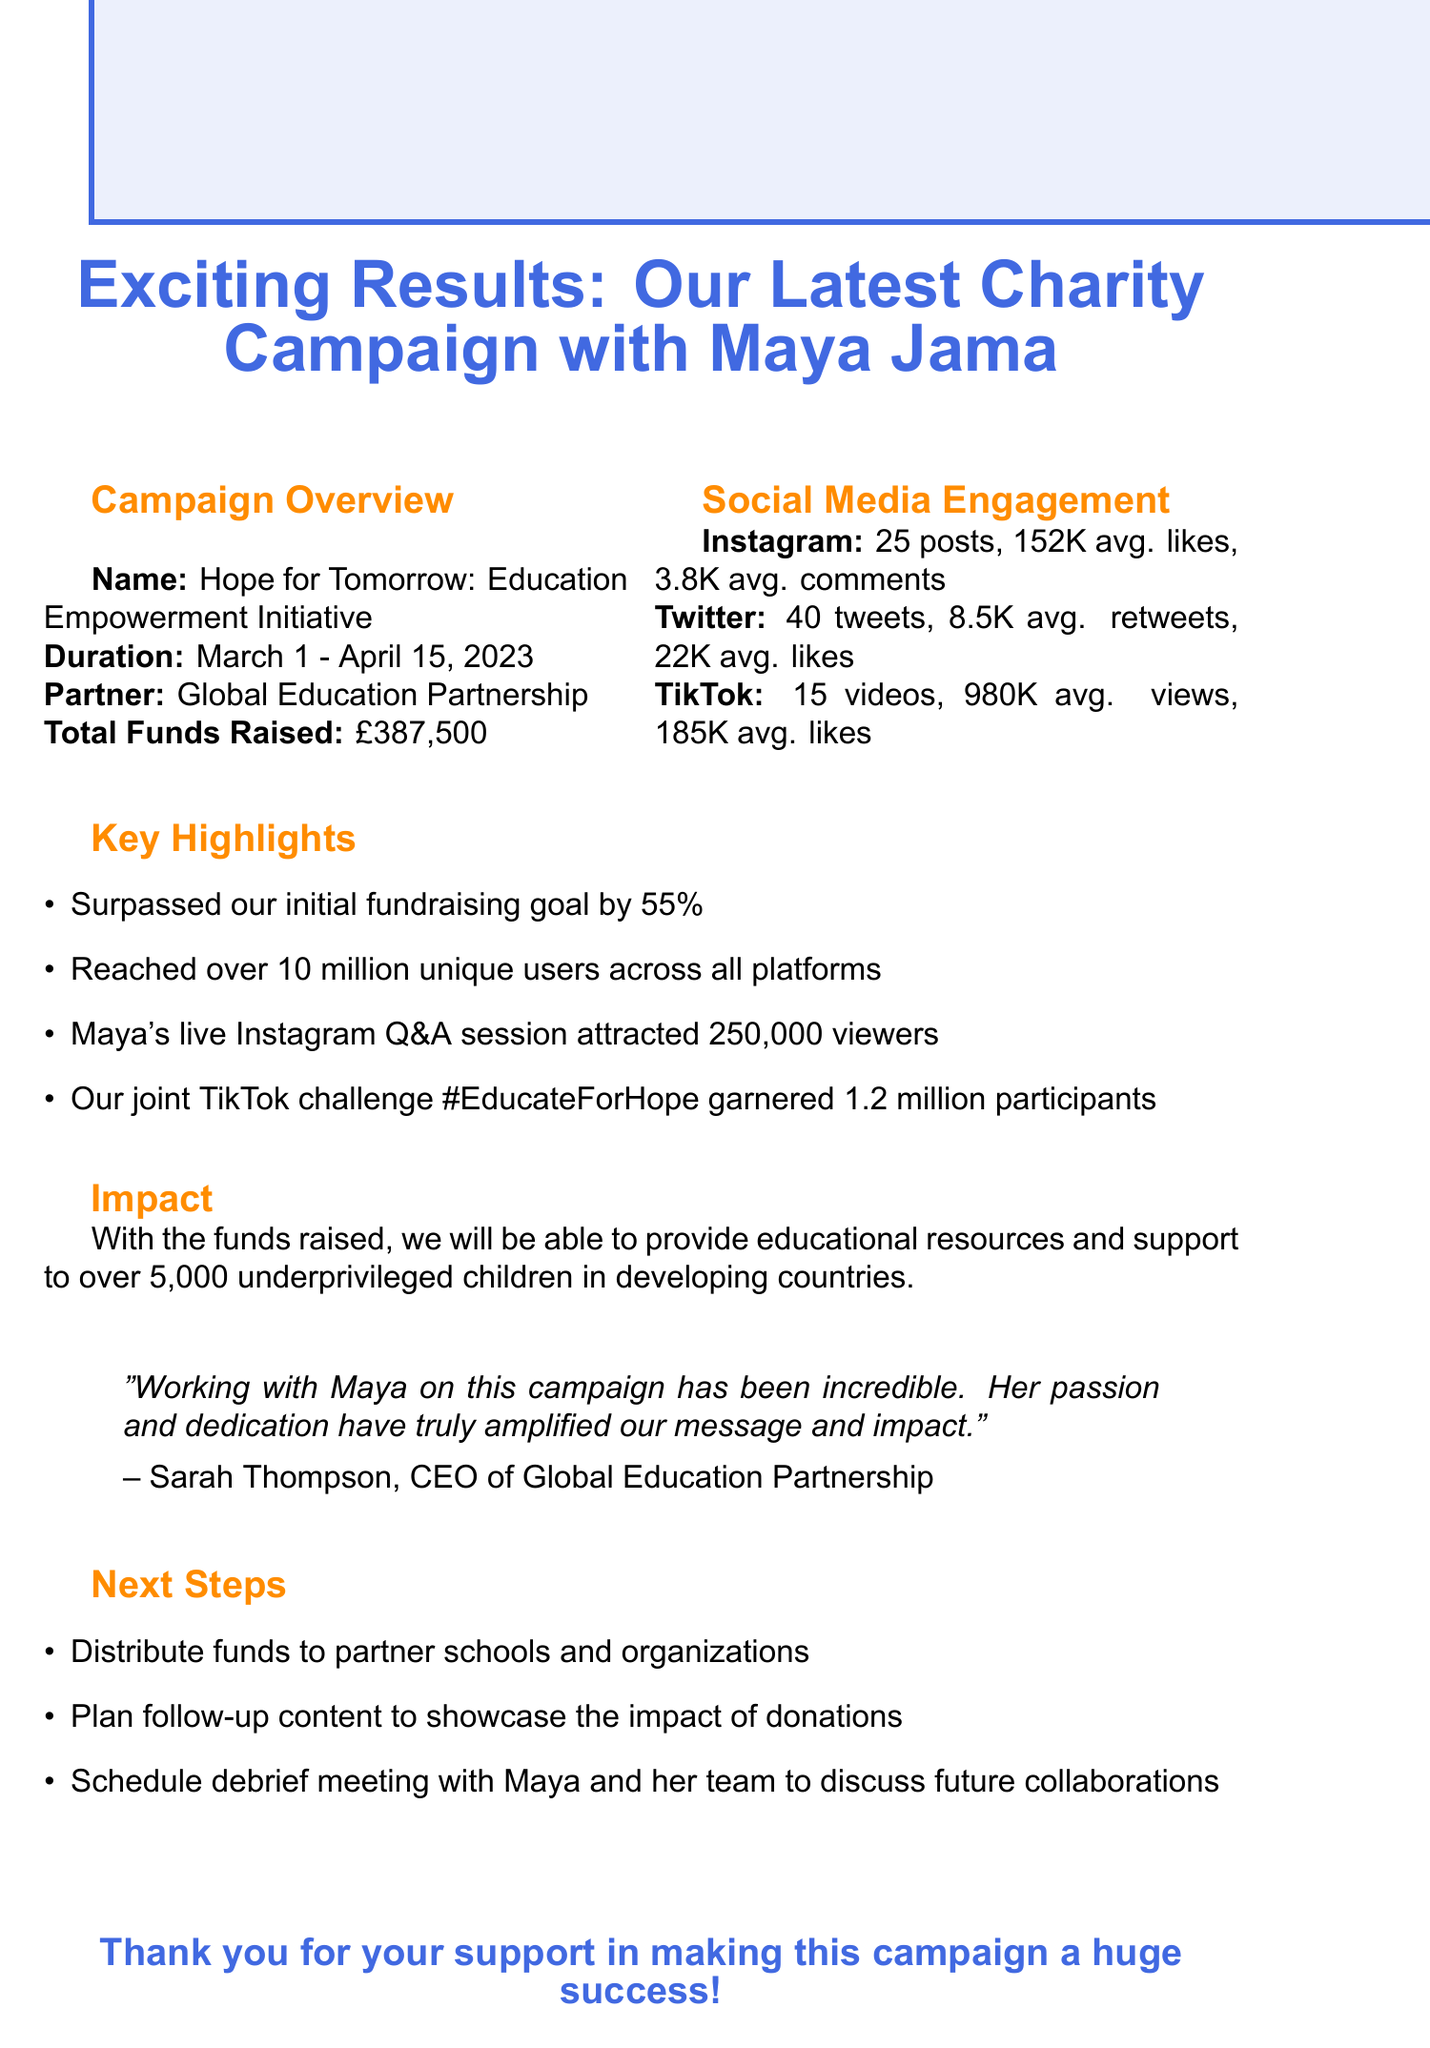What is the campaign name? The campaign name is explicitly stated in the document as "Hope for Tomorrow: Education Empowerment Initiative."
Answer: Hope for Tomorrow: Education Empowerment Initiative What is the total funds raised? The document mentions the total funds raised during the campaign as £387,500.
Answer: £387,500 How many unique users were reached across platforms? The document states that over 10 million unique users were reached across all platforms during the campaign.
Answer: 10 million What was the duration of the campaign? The campaign duration is listed as March 1 - April 15, 2023.
Answer: March 1 - April 15, 2023 Who is the collaborating charity? The collaborating charity is mentioned in the document as "Global Education Partnership."
Answer: Global Education Partnership What percentage did we surpass the initial fundraising goal? The document highlights that the initial fundraising goal was surpassed by 55%.
Answer: 55% How many posts were made on Instagram? The document specifies that there were 25 posts made on Instagram during the campaign.
Answer: 25 What is one of the next steps mentioned in the document? The document includes multiple next steps, including distributing funds to partner schools and organizations.
Answer: Distribute funds to partner schools and organizations What is the impact statement regarding the funds raised? The impact statement explains that the funds will provide educational resources to over 5,000 underprivileged children.
Answer: Provide educational resources and support to over 5,000 underprivileged children 